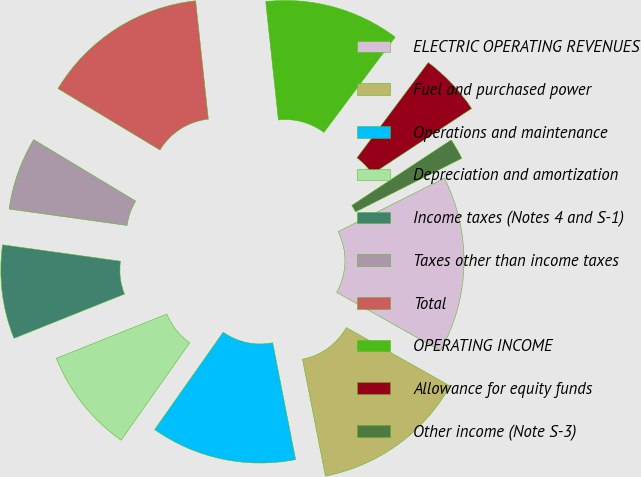Convert chart to OTSL. <chart><loc_0><loc_0><loc_500><loc_500><pie_chart><fcel>ELECTRIC OPERATING REVENUES<fcel>Fuel and purchased power<fcel>Operations and maintenance<fcel>Depreciation and amortization<fcel>Income taxes (Notes 4 and S-1)<fcel>Taxes other than income taxes<fcel>Total<fcel>OPERATING INCOME<fcel>Allowance for equity funds<fcel>Other income (Note S-3)<nl><fcel>15.59%<fcel>13.76%<fcel>12.84%<fcel>9.18%<fcel>8.26%<fcel>6.43%<fcel>14.67%<fcel>11.92%<fcel>5.51%<fcel>1.84%<nl></chart> 